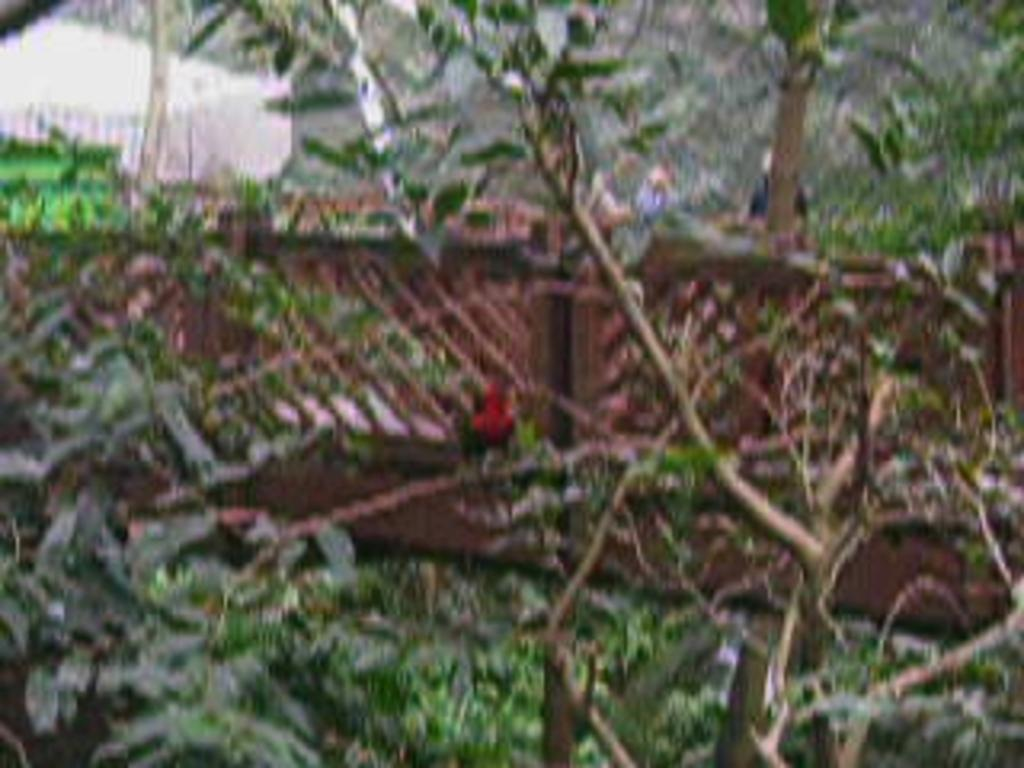What type of living organisms can be seen in the image? Plants can be seen in the image. What is the purpose of the fence in the image? The purpose of the fence in the image is not specified, but it could be for enclosing or separating areas. Can you describe the white object in the background of the image? There is a white object in the background of the image, but its specific details are not clear. What type of shoe is visible in the image? There is no shoe present in the image. What shape is the end of the fence in the image? The shape of the end of the fence in the image is not specified, as the image does not show the end of the fence. 